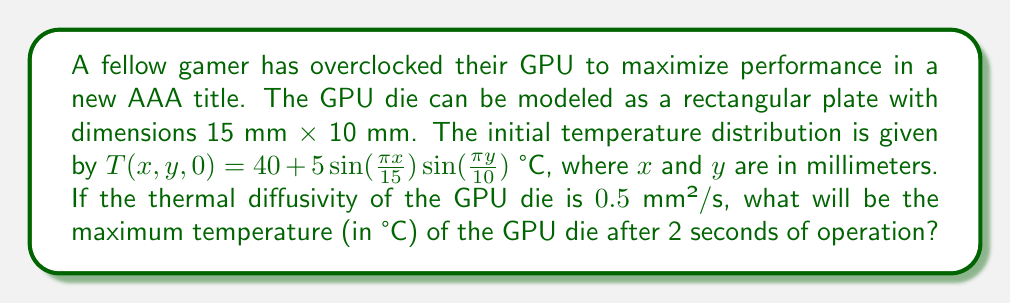Help me with this question. To solve this problem, we'll use the 2D heat equation with the given initial condition. The solution for the temperature distribution at time $t$ is:

$$T(x,y,t) = 40 + 5e^{-\alpha k^2 t}\sin(\frac{\pi x}{15})\sin(\frac{\pi y}{10})$$

Where:
- $\alpha = 0.5$ mm²/s (thermal diffusivity)
- $k^2 = (\frac{\pi}{15})^2 + (\frac{\pi}{10})^2$ (wave number squared)

Step 1: Calculate $k^2$
$$k^2 = (\frac{\pi}{15})^2 + (\frac{\pi}{10})^2 = 0.1374$$

Step 2: Calculate the exponential term for $t = 2$ s
$$e^{-\alpha k^2 t} = e^{-0.5 \cdot 0.1374 \cdot 2} = 0.8725$$

Step 3: The maximum temperature will occur where the sine terms are at their maximum value of 1. So, the maximum temperature is:

$$T_{max} = 40 + 5 \cdot 0.8725 \cdot 1 \cdot 1 = 44.3625 \text{ °C}$$
Answer: 44.36 °C 